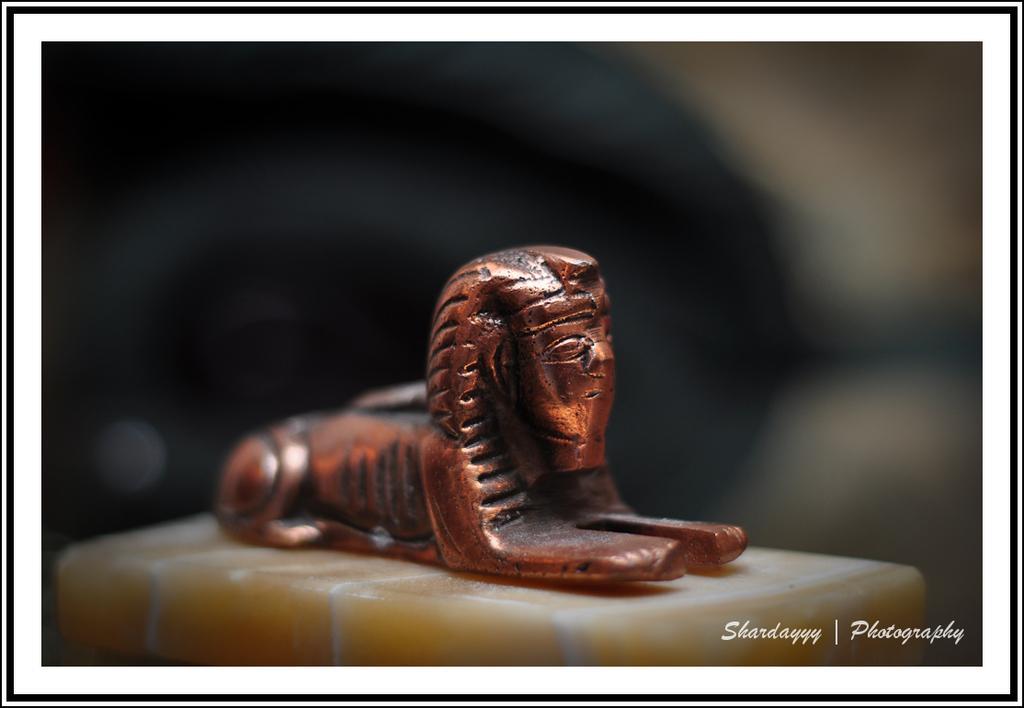In one or two sentences, can you explain what this image depicts? On this surface there is a statue. Background it is blur. Right side bottom of the image there is a watermark. 